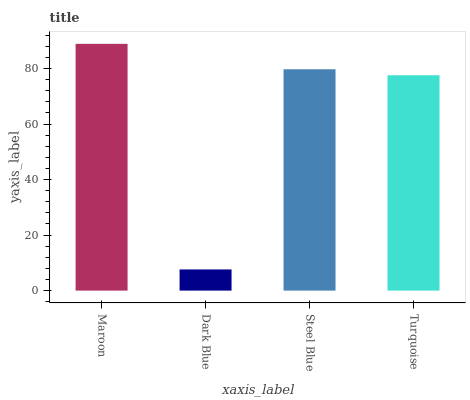Is Dark Blue the minimum?
Answer yes or no. Yes. Is Maroon the maximum?
Answer yes or no. Yes. Is Steel Blue the minimum?
Answer yes or no. No. Is Steel Blue the maximum?
Answer yes or no. No. Is Steel Blue greater than Dark Blue?
Answer yes or no. Yes. Is Dark Blue less than Steel Blue?
Answer yes or no. Yes. Is Dark Blue greater than Steel Blue?
Answer yes or no. No. Is Steel Blue less than Dark Blue?
Answer yes or no. No. Is Steel Blue the high median?
Answer yes or no. Yes. Is Turquoise the low median?
Answer yes or no. Yes. Is Maroon the high median?
Answer yes or no. No. Is Maroon the low median?
Answer yes or no. No. 